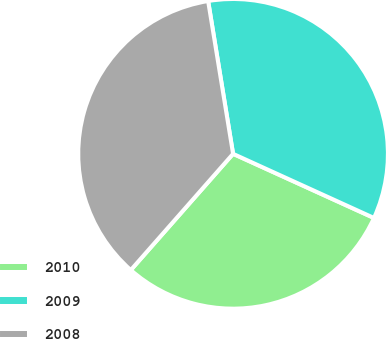<chart> <loc_0><loc_0><loc_500><loc_500><pie_chart><fcel>2010<fcel>2009<fcel>2008<nl><fcel>29.69%<fcel>34.38%<fcel>35.94%<nl></chart> 